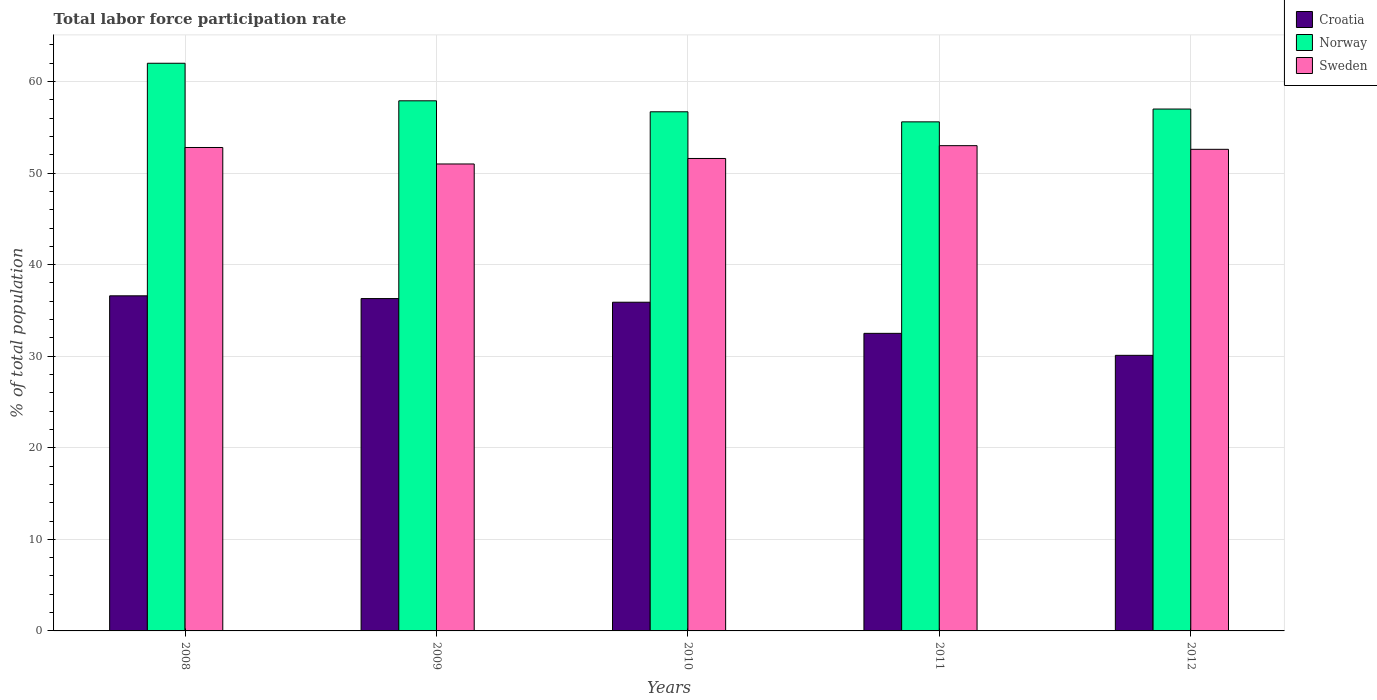How many groups of bars are there?
Your answer should be very brief. 5. Are the number of bars on each tick of the X-axis equal?
Keep it short and to the point. Yes. What is the label of the 2nd group of bars from the left?
Provide a short and direct response. 2009. What is the total labor force participation rate in Sweden in 2008?
Give a very brief answer. 52.8. Across all years, what is the minimum total labor force participation rate in Croatia?
Keep it short and to the point. 30.1. In which year was the total labor force participation rate in Croatia maximum?
Keep it short and to the point. 2008. In which year was the total labor force participation rate in Croatia minimum?
Offer a very short reply. 2012. What is the total total labor force participation rate in Sweden in the graph?
Offer a very short reply. 261. What is the difference between the total labor force participation rate in Croatia in 2011 and that in 2012?
Give a very brief answer. 2.4. What is the difference between the total labor force participation rate in Croatia in 2010 and the total labor force participation rate in Norway in 2012?
Offer a very short reply. -21.1. What is the average total labor force participation rate in Sweden per year?
Make the answer very short. 52.2. In the year 2009, what is the difference between the total labor force participation rate in Norway and total labor force participation rate in Croatia?
Make the answer very short. 21.6. In how many years, is the total labor force participation rate in Norway greater than 32 %?
Give a very brief answer. 5. What is the ratio of the total labor force participation rate in Croatia in 2008 to that in 2010?
Make the answer very short. 1.02. What is the difference between the highest and the second highest total labor force participation rate in Sweden?
Offer a terse response. 0.2. What is the difference between the highest and the lowest total labor force participation rate in Croatia?
Give a very brief answer. 6.5. In how many years, is the total labor force participation rate in Norway greater than the average total labor force participation rate in Norway taken over all years?
Provide a succinct answer. 2. What does the 3rd bar from the left in 2012 represents?
Make the answer very short. Sweden. What does the 3rd bar from the right in 2008 represents?
Provide a short and direct response. Croatia. Is it the case that in every year, the sum of the total labor force participation rate in Norway and total labor force participation rate in Sweden is greater than the total labor force participation rate in Croatia?
Offer a very short reply. Yes. How many bars are there?
Provide a succinct answer. 15. Are all the bars in the graph horizontal?
Ensure brevity in your answer.  No. Are the values on the major ticks of Y-axis written in scientific E-notation?
Provide a succinct answer. No. Does the graph contain any zero values?
Provide a short and direct response. No. Does the graph contain grids?
Your answer should be very brief. Yes. What is the title of the graph?
Keep it short and to the point. Total labor force participation rate. What is the label or title of the Y-axis?
Keep it short and to the point. % of total population. What is the % of total population of Croatia in 2008?
Your response must be concise. 36.6. What is the % of total population in Norway in 2008?
Your answer should be very brief. 62. What is the % of total population in Sweden in 2008?
Your answer should be very brief. 52.8. What is the % of total population in Croatia in 2009?
Make the answer very short. 36.3. What is the % of total population in Norway in 2009?
Keep it short and to the point. 57.9. What is the % of total population of Croatia in 2010?
Your answer should be compact. 35.9. What is the % of total population in Norway in 2010?
Give a very brief answer. 56.7. What is the % of total population of Sweden in 2010?
Your answer should be very brief. 51.6. What is the % of total population of Croatia in 2011?
Make the answer very short. 32.5. What is the % of total population of Norway in 2011?
Your answer should be very brief. 55.6. What is the % of total population of Croatia in 2012?
Keep it short and to the point. 30.1. What is the % of total population in Sweden in 2012?
Provide a succinct answer. 52.6. Across all years, what is the maximum % of total population in Croatia?
Make the answer very short. 36.6. Across all years, what is the maximum % of total population in Sweden?
Give a very brief answer. 53. Across all years, what is the minimum % of total population in Croatia?
Offer a very short reply. 30.1. Across all years, what is the minimum % of total population of Norway?
Your answer should be very brief. 55.6. Across all years, what is the minimum % of total population in Sweden?
Your answer should be compact. 51. What is the total % of total population in Croatia in the graph?
Provide a succinct answer. 171.4. What is the total % of total population in Norway in the graph?
Your response must be concise. 289.2. What is the total % of total population of Sweden in the graph?
Offer a terse response. 261. What is the difference between the % of total population of Norway in 2008 and that in 2009?
Give a very brief answer. 4.1. What is the difference between the % of total population of Sweden in 2008 and that in 2009?
Provide a short and direct response. 1.8. What is the difference between the % of total population of Sweden in 2008 and that in 2010?
Your answer should be compact. 1.2. What is the difference between the % of total population in Croatia in 2008 and that in 2011?
Provide a short and direct response. 4.1. What is the difference between the % of total population of Norway in 2008 and that in 2011?
Your response must be concise. 6.4. What is the difference between the % of total population in Croatia in 2008 and that in 2012?
Your answer should be compact. 6.5. What is the difference between the % of total population of Croatia in 2009 and that in 2010?
Your answer should be compact. 0.4. What is the difference between the % of total population of Norway in 2009 and that in 2010?
Provide a short and direct response. 1.2. What is the difference between the % of total population in Sweden in 2009 and that in 2010?
Your answer should be very brief. -0.6. What is the difference between the % of total population of Croatia in 2009 and that in 2011?
Provide a short and direct response. 3.8. What is the difference between the % of total population in Sweden in 2009 and that in 2011?
Give a very brief answer. -2. What is the difference between the % of total population of Croatia in 2010 and that in 2011?
Keep it short and to the point. 3.4. What is the difference between the % of total population in Norway in 2010 and that in 2011?
Provide a short and direct response. 1.1. What is the difference between the % of total population in Sweden in 2010 and that in 2011?
Keep it short and to the point. -1.4. What is the difference between the % of total population in Croatia in 2011 and that in 2012?
Your answer should be compact. 2.4. What is the difference between the % of total population in Norway in 2011 and that in 2012?
Give a very brief answer. -1.4. What is the difference between the % of total population of Croatia in 2008 and the % of total population of Norway in 2009?
Your answer should be very brief. -21.3. What is the difference between the % of total population of Croatia in 2008 and the % of total population of Sweden in 2009?
Offer a terse response. -14.4. What is the difference between the % of total population of Norway in 2008 and the % of total population of Sweden in 2009?
Ensure brevity in your answer.  11. What is the difference between the % of total population in Croatia in 2008 and the % of total population in Norway in 2010?
Give a very brief answer. -20.1. What is the difference between the % of total population of Croatia in 2008 and the % of total population of Sweden in 2010?
Offer a terse response. -15. What is the difference between the % of total population of Croatia in 2008 and the % of total population of Sweden in 2011?
Give a very brief answer. -16.4. What is the difference between the % of total population in Norway in 2008 and the % of total population in Sweden in 2011?
Your response must be concise. 9. What is the difference between the % of total population in Croatia in 2008 and the % of total population in Norway in 2012?
Provide a succinct answer. -20.4. What is the difference between the % of total population of Croatia in 2008 and the % of total population of Sweden in 2012?
Provide a short and direct response. -16. What is the difference between the % of total population in Croatia in 2009 and the % of total population in Norway in 2010?
Ensure brevity in your answer.  -20.4. What is the difference between the % of total population of Croatia in 2009 and the % of total population of Sweden in 2010?
Offer a terse response. -15.3. What is the difference between the % of total population in Croatia in 2009 and the % of total population in Norway in 2011?
Your answer should be very brief. -19.3. What is the difference between the % of total population in Croatia in 2009 and the % of total population in Sweden in 2011?
Make the answer very short. -16.7. What is the difference between the % of total population of Norway in 2009 and the % of total population of Sweden in 2011?
Provide a succinct answer. 4.9. What is the difference between the % of total population in Croatia in 2009 and the % of total population in Norway in 2012?
Keep it short and to the point. -20.7. What is the difference between the % of total population in Croatia in 2009 and the % of total population in Sweden in 2012?
Ensure brevity in your answer.  -16.3. What is the difference between the % of total population of Norway in 2009 and the % of total population of Sweden in 2012?
Make the answer very short. 5.3. What is the difference between the % of total population in Croatia in 2010 and the % of total population in Norway in 2011?
Offer a very short reply. -19.7. What is the difference between the % of total population in Croatia in 2010 and the % of total population in Sweden in 2011?
Offer a terse response. -17.1. What is the difference between the % of total population of Croatia in 2010 and the % of total population of Norway in 2012?
Your response must be concise. -21.1. What is the difference between the % of total population of Croatia in 2010 and the % of total population of Sweden in 2012?
Offer a terse response. -16.7. What is the difference between the % of total population of Norway in 2010 and the % of total population of Sweden in 2012?
Provide a short and direct response. 4.1. What is the difference between the % of total population in Croatia in 2011 and the % of total population in Norway in 2012?
Keep it short and to the point. -24.5. What is the difference between the % of total population in Croatia in 2011 and the % of total population in Sweden in 2012?
Your answer should be very brief. -20.1. What is the average % of total population in Croatia per year?
Give a very brief answer. 34.28. What is the average % of total population of Norway per year?
Your response must be concise. 57.84. What is the average % of total population in Sweden per year?
Provide a succinct answer. 52.2. In the year 2008, what is the difference between the % of total population of Croatia and % of total population of Norway?
Ensure brevity in your answer.  -25.4. In the year 2008, what is the difference between the % of total population of Croatia and % of total population of Sweden?
Give a very brief answer. -16.2. In the year 2008, what is the difference between the % of total population of Norway and % of total population of Sweden?
Your answer should be compact. 9.2. In the year 2009, what is the difference between the % of total population of Croatia and % of total population of Norway?
Ensure brevity in your answer.  -21.6. In the year 2009, what is the difference between the % of total population in Croatia and % of total population in Sweden?
Your response must be concise. -14.7. In the year 2010, what is the difference between the % of total population of Croatia and % of total population of Norway?
Ensure brevity in your answer.  -20.8. In the year 2010, what is the difference between the % of total population in Croatia and % of total population in Sweden?
Provide a short and direct response. -15.7. In the year 2011, what is the difference between the % of total population in Croatia and % of total population in Norway?
Ensure brevity in your answer.  -23.1. In the year 2011, what is the difference between the % of total population in Croatia and % of total population in Sweden?
Offer a very short reply. -20.5. In the year 2012, what is the difference between the % of total population of Croatia and % of total population of Norway?
Your answer should be very brief. -26.9. In the year 2012, what is the difference between the % of total population in Croatia and % of total population in Sweden?
Provide a short and direct response. -22.5. In the year 2012, what is the difference between the % of total population in Norway and % of total population in Sweden?
Ensure brevity in your answer.  4.4. What is the ratio of the % of total population of Croatia in 2008 to that in 2009?
Provide a short and direct response. 1.01. What is the ratio of the % of total population of Norway in 2008 to that in 2009?
Provide a short and direct response. 1.07. What is the ratio of the % of total population of Sweden in 2008 to that in 2009?
Make the answer very short. 1.04. What is the ratio of the % of total population in Croatia in 2008 to that in 2010?
Your answer should be very brief. 1.02. What is the ratio of the % of total population of Norway in 2008 to that in 2010?
Ensure brevity in your answer.  1.09. What is the ratio of the % of total population in Sweden in 2008 to that in 2010?
Your answer should be very brief. 1.02. What is the ratio of the % of total population in Croatia in 2008 to that in 2011?
Keep it short and to the point. 1.13. What is the ratio of the % of total population of Norway in 2008 to that in 2011?
Offer a very short reply. 1.12. What is the ratio of the % of total population of Croatia in 2008 to that in 2012?
Ensure brevity in your answer.  1.22. What is the ratio of the % of total population in Norway in 2008 to that in 2012?
Offer a very short reply. 1.09. What is the ratio of the % of total population of Croatia in 2009 to that in 2010?
Offer a very short reply. 1.01. What is the ratio of the % of total population in Norway in 2009 to that in 2010?
Provide a short and direct response. 1.02. What is the ratio of the % of total population in Sweden in 2009 to that in 2010?
Offer a terse response. 0.99. What is the ratio of the % of total population of Croatia in 2009 to that in 2011?
Provide a succinct answer. 1.12. What is the ratio of the % of total population of Norway in 2009 to that in 2011?
Provide a short and direct response. 1.04. What is the ratio of the % of total population of Sweden in 2009 to that in 2011?
Your answer should be compact. 0.96. What is the ratio of the % of total population of Croatia in 2009 to that in 2012?
Ensure brevity in your answer.  1.21. What is the ratio of the % of total population of Norway in 2009 to that in 2012?
Offer a very short reply. 1.02. What is the ratio of the % of total population of Sweden in 2009 to that in 2012?
Offer a very short reply. 0.97. What is the ratio of the % of total population of Croatia in 2010 to that in 2011?
Offer a terse response. 1.1. What is the ratio of the % of total population of Norway in 2010 to that in 2011?
Provide a short and direct response. 1.02. What is the ratio of the % of total population of Sweden in 2010 to that in 2011?
Your answer should be very brief. 0.97. What is the ratio of the % of total population of Croatia in 2010 to that in 2012?
Ensure brevity in your answer.  1.19. What is the ratio of the % of total population of Sweden in 2010 to that in 2012?
Your answer should be very brief. 0.98. What is the ratio of the % of total population of Croatia in 2011 to that in 2012?
Provide a short and direct response. 1.08. What is the ratio of the % of total population of Norway in 2011 to that in 2012?
Provide a short and direct response. 0.98. What is the ratio of the % of total population of Sweden in 2011 to that in 2012?
Ensure brevity in your answer.  1.01. What is the difference between the highest and the second highest % of total population in Croatia?
Offer a terse response. 0.3. What is the difference between the highest and the second highest % of total population of Norway?
Give a very brief answer. 4.1. What is the difference between the highest and the second highest % of total population in Sweden?
Your answer should be compact. 0.2. What is the difference between the highest and the lowest % of total population of Croatia?
Provide a short and direct response. 6.5. What is the difference between the highest and the lowest % of total population of Sweden?
Make the answer very short. 2. 